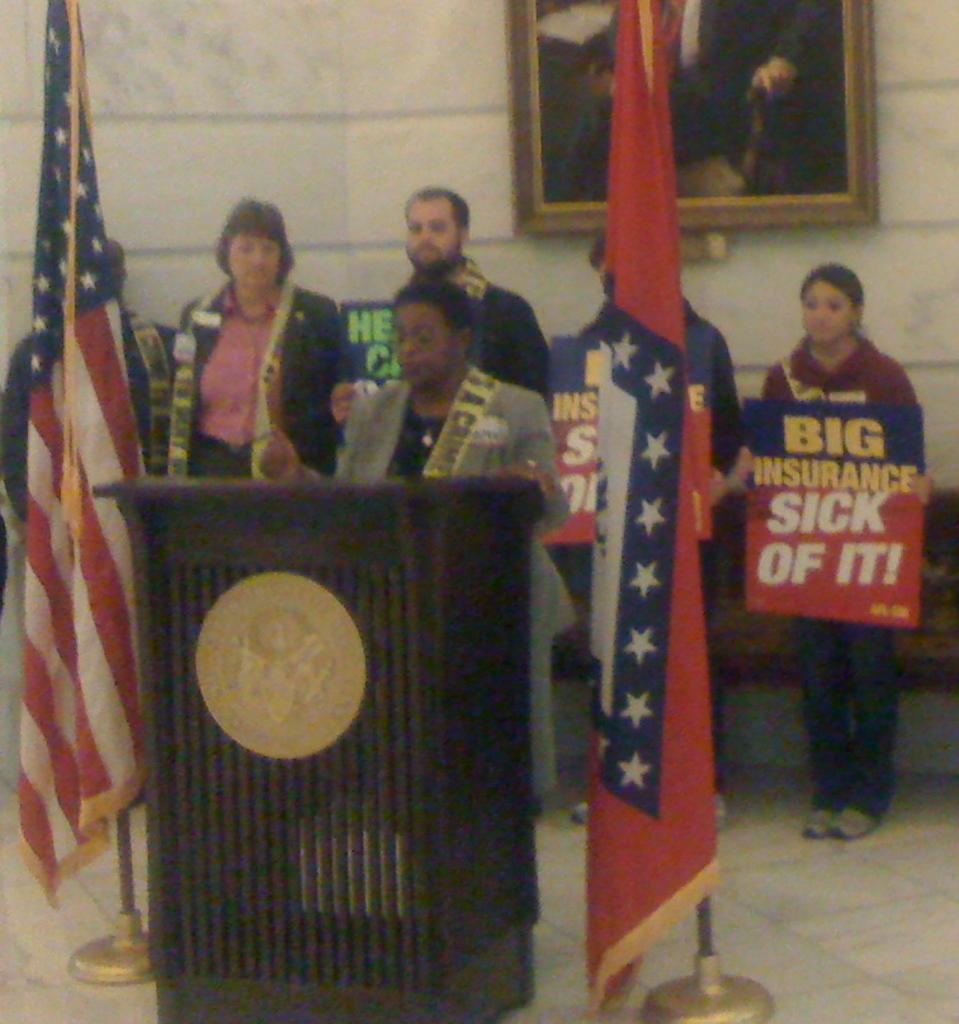<image>
Render a clear and concise summary of the photo. Woman in the back holding a red sign which says "Sick of it". 